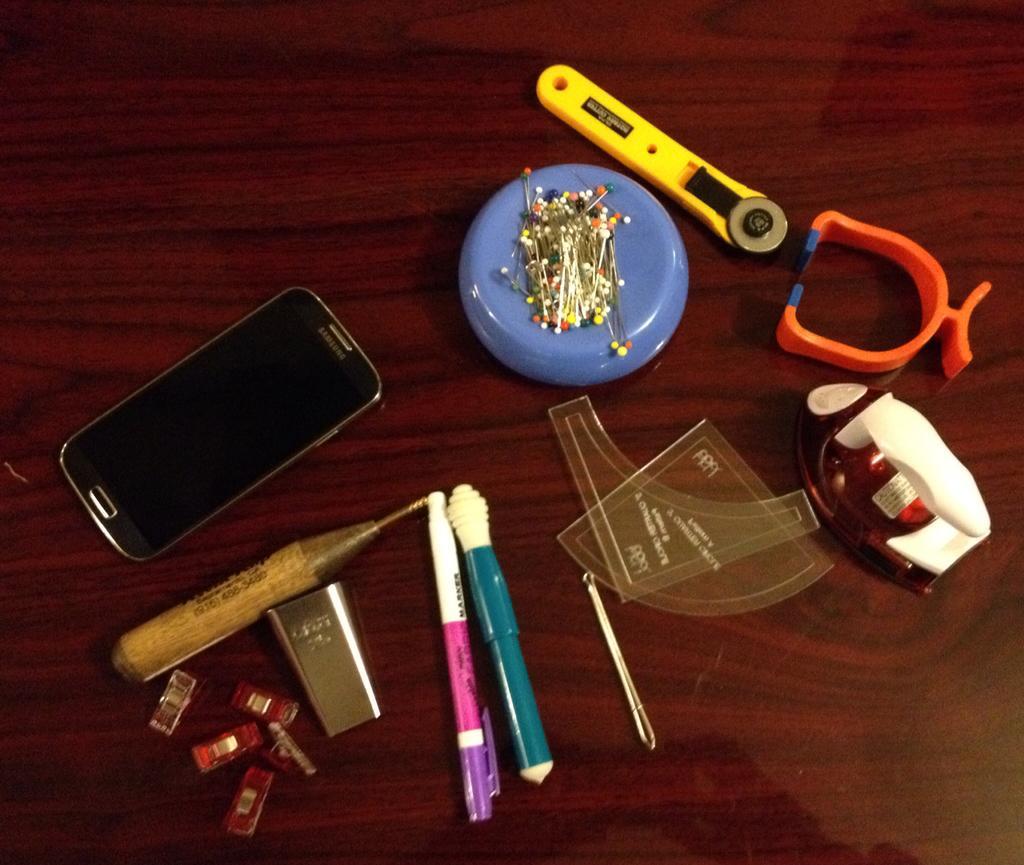Please provide a concise description of this image. In this image there is a mobile, magnet with plastic head pins on it , pen and some other objects on the wooden board. 